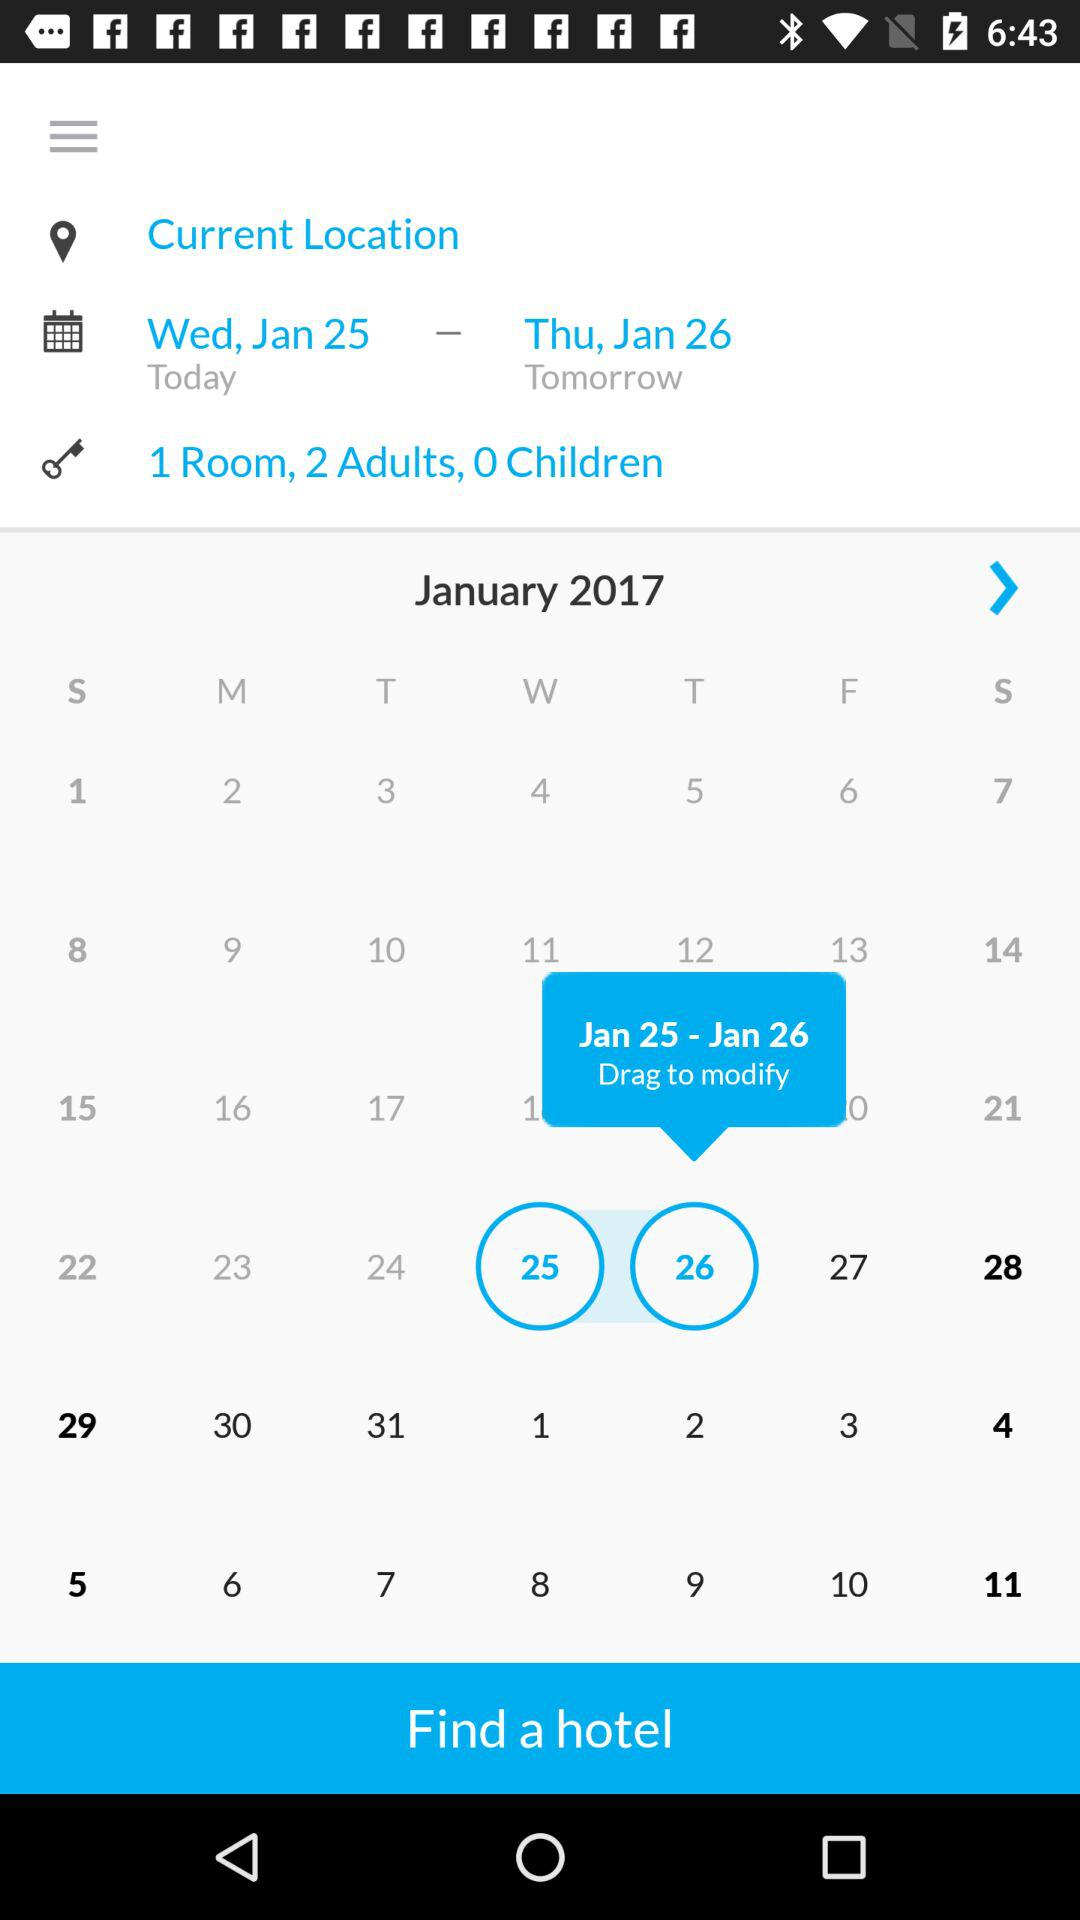What is the minimum number of rooms available?
Answer the question using a single word or phrase. 1 